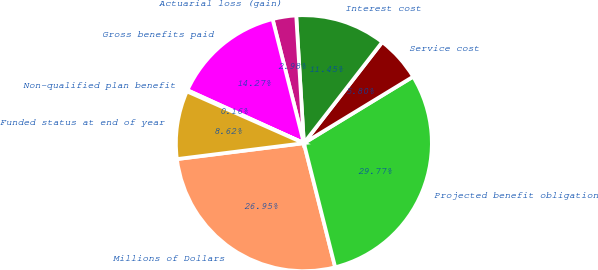<chart> <loc_0><loc_0><loc_500><loc_500><pie_chart><fcel>Millions of Dollars<fcel>Projected benefit obligation<fcel>Service cost<fcel>Interest cost<fcel>Actuarial loss (gain)<fcel>Gross benefits paid<fcel>Non-qualified plan benefit<fcel>Funded status at end of year<nl><fcel>26.95%<fcel>29.77%<fcel>5.8%<fcel>11.45%<fcel>2.98%<fcel>14.27%<fcel>0.16%<fcel>8.62%<nl></chart> 